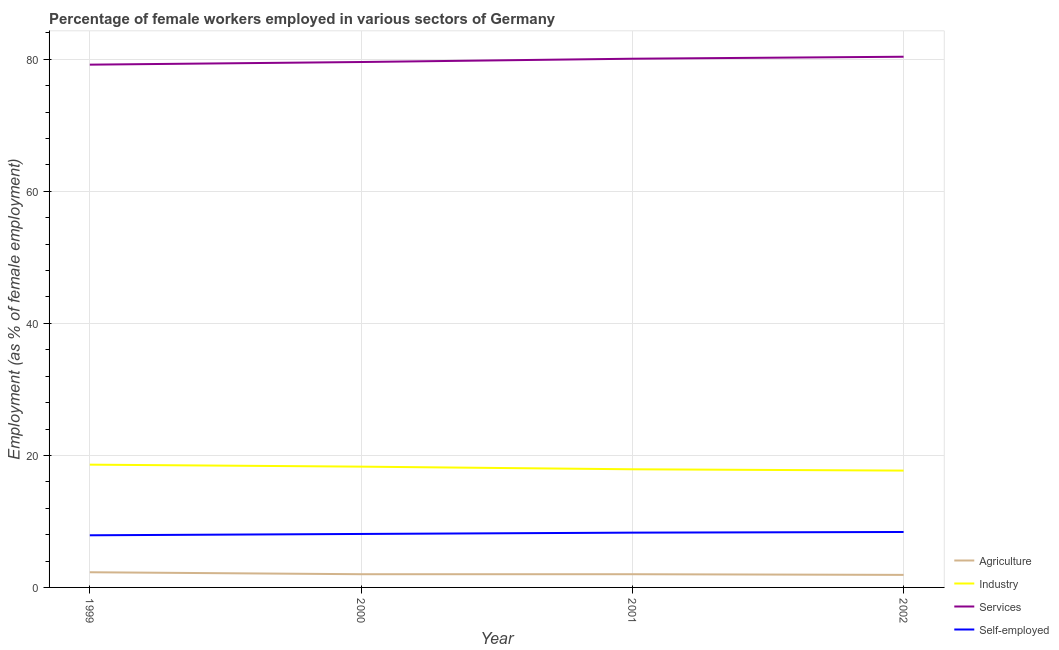How many different coloured lines are there?
Your answer should be very brief. 4. What is the percentage of female workers in industry in 2002?
Provide a short and direct response. 17.7. Across all years, what is the maximum percentage of self employed female workers?
Offer a very short reply. 8.4. Across all years, what is the minimum percentage of female workers in services?
Make the answer very short. 79.2. In which year was the percentage of self employed female workers minimum?
Give a very brief answer. 1999. What is the total percentage of self employed female workers in the graph?
Ensure brevity in your answer.  32.7. What is the difference between the percentage of self employed female workers in 2000 and that in 2002?
Your answer should be very brief. -0.3. What is the difference between the percentage of self employed female workers in 2002 and the percentage of female workers in services in 1999?
Give a very brief answer. -70.8. What is the average percentage of female workers in industry per year?
Keep it short and to the point. 18.12. In the year 2001, what is the difference between the percentage of self employed female workers and percentage of female workers in agriculture?
Offer a very short reply. 6.3. What is the ratio of the percentage of female workers in services in 2001 to that in 2002?
Keep it short and to the point. 1. What is the difference between the highest and the second highest percentage of female workers in services?
Your response must be concise. 0.3. What is the difference between the highest and the lowest percentage of female workers in agriculture?
Your answer should be compact. 0.4. In how many years, is the percentage of female workers in industry greater than the average percentage of female workers in industry taken over all years?
Give a very brief answer. 2. Does the percentage of female workers in agriculture monotonically increase over the years?
Offer a terse response. No. Is the percentage of female workers in agriculture strictly less than the percentage of female workers in services over the years?
Offer a very short reply. Yes. Are the values on the major ticks of Y-axis written in scientific E-notation?
Offer a terse response. No. Does the graph contain grids?
Ensure brevity in your answer.  Yes. How are the legend labels stacked?
Offer a terse response. Vertical. What is the title of the graph?
Give a very brief answer. Percentage of female workers employed in various sectors of Germany. Does "United Kingdom" appear as one of the legend labels in the graph?
Your response must be concise. No. What is the label or title of the Y-axis?
Ensure brevity in your answer.  Employment (as % of female employment). What is the Employment (as % of female employment) in Agriculture in 1999?
Provide a short and direct response. 2.3. What is the Employment (as % of female employment) of Industry in 1999?
Provide a short and direct response. 18.6. What is the Employment (as % of female employment) in Services in 1999?
Your answer should be compact. 79.2. What is the Employment (as % of female employment) of Self-employed in 1999?
Provide a short and direct response. 7.9. What is the Employment (as % of female employment) of Agriculture in 2000?
Keep it short and to the point. 2. What is the Employment (as % of female employment) of Industry in 2000?
Offer a terse response. 18.3. What is the Employment (as % of female employment) in Services in 2000?
Keep it short and to the point. 79.6. What is the Employment (as % of female employment) in Self-employed in 2000?
Make the answer very short. 8.1. What is the Employment (as % of female employment) of Agriculture in 2001?
Ensure brevity in your answer.  2. What is the Employment (as % of female employment) in Industry in 2001?
Provide a succinct answer. 17.9. What is the Employment (as % of female employment) in Services in 2001?
Make the answer very short. 80.1. What is the Employment (as % of female employment) in Self-employed in 2001?
Keep it short and to the point. 8.3. What is the Employment (as % of female employment) in Agriculture in 2002?
Offer a terse response. 1.9. What is the Employment (as % of female employment) of Industry in 2002?
Your response must be concise. 17.7. What is the Employment (as % of female employment) of Services in 2002?
Make the answer very short. 80.4. What is the Employment (as % of female employment) of Self-employed in 2002?
Provide a short and direct response. 8.4. Across all years, what is the maximum Employment (as % of female employment) in Agriculture?
Give a very brief answer. 2.3. Across all years, what is the maximum Employment (as % of female employment) in Industry?
Your answer should be compact. 18.6. Across all years, what is the maximum Employment (as % of female employment) in Services?
Give a very brief answer. 80.4. Across all years, what is the maximum Employment (as % of female employment) of Self-employed?
Provide a short and direct response. 8.4. Across all years, what is the minimum Employment (as % of female employment) in Agriculture?
Provide a succinct answer. 1.9. Across all years, what is the minimum Employment (as % of female employment) of Industry?
Offer a terse response. 17.7. Across all years, what is the minimum Employment (as % of female employment) of Services?
Make the answer very short. 79.2. Across all years, what is the minimum Employment (as % of female employment) of Self-employed?
Make the answer very short. 7.9. What is the total Employment (as % of female employment) in Agriculture in the graph?
Provide a short and direct response. 8.2. What is the total Employment (as % of female employment) in Industry in the graph?
Your answer should be compact. 72.5. What is the total Employment (as % of female employment) of Services in the graph?
Ensure brevity in your answer.  319.3. What is the total Employment (as % of female employment) of Self-employed in the graph?
Your answer should be very brief. 32.7. What is the difference between the Employment (as % of female employment) in Agriculture in 1999 and that in 2000?
Keep it short and to the point. 0.3. What is the difference between the Employment (as % of female employment) of Industry in 1999 and that in 2000?
Your answer should be compact. 0.3. What is the difference between the Employment (as % of female employment) of Self-employed in 1999 and that in 2000?
Make the answer very short. -0.2. What is the difference between the Employment (as % of female employment) of Agriculture in 1999 and that in 2001?
Your answer should be compact. 0.3. What is the difference between the Employment (as % of female employment) of Services in 1999 and that in 2001?
Offer a very short reply. -0.9. What is the difference between the Employment (as % of female employment) in Self-employed in 1999 and that in 2001?
Your answer should be very brief. -0.4. What is the difference between the Employment (as % of female employment) in Services in 1999 and that in 2002?
Provide a short and direct response. -1.2. What is the difference between the Employment (as % of female employment) in Self-employed in 1999 and that in 2002?
Your answer should be compact. -0.5. What is the difference between the Employment (as % of female employment) in Self-employed in 2000 and that in 2001?
Offer a terse response. -0.2. What is the difference between the Employment (as % of female employment) of Agriculture in 2000 and that in 2002?
Your response must be concise. 0.1. What is the difference between the Employment (as % of female employment) of Industry in 2000 and that in 2002?
Your answer should be very brief. 0.6. What is the difference between the Employment (as % of female employment) in Services in 2000 and that in 2002?
Your response must be concise. -0.8. What is the difference between the Employment (as % of female employment) of Agriculture in 2001 and that in 2002?
Your response must be concise. 0.1. What is the difference between the Employment (as % of female employment) of Agriculture in 1999 and the Employment (as % of female employment) of Services in 2000?
Your answer should be compact. -77.3. What is the difference between the Employment (as % of female employment) of Agriculture in 1999 and the Employment (as % of female employment) of Self-employed in 2000?
Ensure brevity in your answer.  -5.8. What is the difference between the Employment (as % of female employment) in Industry in 1999 and the Employment (as % of female employment) in Services in 2000?
Make the answer very short. -61. What is the difference between the Employment (as % of female employment) in Industry in 1999 and the Employment (as % of female employment) in Self-employed in 2000?
Ensure brevity in your answer.  10.5. What is the difference between the Employment (as % of female employment) of Services in 1999 and the Employment (as % of female employment) of Self-employed in 2000?
Your response must be concise. 71.1. What is the difference between the Employment (as % of female employment) in Agriculture in 1999 and the Employment (as % of female employment) in Industry in 2001?
Give a very brief answer. -15.6. What is the difference between the Employment (as % of female employment) of Agriculture in 1999 and the Employment (as % of female employment) of Services in 2001?
Your answer should be compact. -77.8. What is the difference between the Employment (as % of female employment) of Industry in 1999 and the Employment (as % of female employment) of Services in 2001?
Provide a short and direct response. -61.5. What is the difference between the Employment (as % of female employment) in Services in 1999 and the Employment (as % of female employment) in Self-employed in 2001?
Your answer should be compact. 70.9. What is the difference between the Employment (as % of female employment) in Agriculture in 1999 and the Employment (as % of female employment) in Industry in 2002?
Provide a succinct answer. -15.4. What is the difference between the Employment (as % of female employment) of Agriculture in 1999 and the Employment (as % of female employment) of Services in 2002?
Your answer should be very brief. -78.1. What is the difference between the Employment (as % of female employment) in Industry in 1999 and the Employment (as % of female employment) in Services in 2002?
Give a very brief answer. -61.8. What is the difference between the Employment (as % of female employment) of Services in 1999 and the Employment (as % of female employment) of Self-employed in 2002?
Your response must be concise. 70.8. What is the difference between the Employment (as % of female employment) of Agriculture in 2000 and the Employment (as % of female employment) of Industry in 2001?
Your answer should be compact. -15.9. What is the difference between the Employment (as % of female employment) in Agriculture in 2000 and the Employment (as % of female employment) in Services in 2001?
Give a very brief answer. -78.1. What is the difference between the Employment (as % of female employment) in Industry in 2000 and the Employment (as % of female employment) in Services in 2001?
Keep it short and to the point. -61.8. What is the difference between the Employment (as % of female employment) in Industry in 2000 and the Employment (as % of female employment) in Self-employed in 2001?
Your response must be concise. 10. What is the difference between the Employment (as % of female employment) in Services in 2000 and the Employment (as % of female employment) in Self-employed in 2001?
Offer a very short reply. 71.3. What is the difference between the Employment (as % of female employment) in Agriculture in 2000 and the Employment (as % of female employment) in Industry in 2002?
Give a very brief answer. -15.7. What is the difference between the Employment (as % of female employment) in Agriculture in 2000 and the Employment (as % of female employment) in Services in 2002?
Your answer should be compact. -78.4. What is the difference between the Employment (as % of female employment) of Industry in 2000 and the Employment (as % of female employment) of Services in 2002?
Ensure brevity in your answer.  -62.1. What is the difference between the Employment (as % of female employment) in Industry in 2000 and the Employment (as % of female employment) in Self-employed in 2002?
Make the answer very short. 9.9. What is the difference between the Employment (as % of female employment) of Services in 2000 and the Employment (as % of female employment) of Self-employed in 2002?
Your response must be concise. 71.2. What is the difference between the Employment (as % of female employment) in Agriculture in 2001 and the Employment (as % of female employment) in Industry in 2002?
Keep it short and to the point. -15.7. What is the difference between the Employment (as % of female employment) in Agriculture in 2001 and the Employment (as % of female employment) in Services in 2002?
Give a very brief answer. -78.4. What is the difference between the Employment (as % of female employment) of Agriculture in 2001 and the Employment (as % of female employment) of Self-employed in 2002?
Provide a succinct answer. -6.4. What is the difference between the Employment (as % of female employment) in Industry in 2001 and the Employment (as % of female employment) in Services in 2002?
Give a very brief answer. -62.5. What is the difference between the Employment (as % of female employment) of Industry in 2001 and the Employment (as % of female employment) of Self-employed in 2002?
Give a very brief answer. 9.5. What is the difference between the Employment (as % of female employment) of Services in 2001 and the Employment (as % of female employment) of Self-employed in 2002?
Offer a terse response. 71.7. What is the average Employment (as % of female employment) of Agriculture per year?
Give a very brief answer. 2.05. What is the average Employment (as % of female employment) in Industry per year?
Provide a succinct answer. 18.12. What is the average Employment (as % of female employment) in Services per year?
Provide a succinct answer. 79.83. What is the average Employment (as % of female employment) of Self-employed per year?
Keep it short and to the point. 8.18. In the year 1999, what is the difference between the Employment (as % of female employment) of Agriculture and Employment (as % of female employment) of Industry?
Provide a succinct answer. -16.3. In the year 1999, what is the difference between the Employment (as % of female employment) of Agriculture and Employment (as % of female employment) of Services?
Provide a short and direct response. -76.9. In the year 1999, what is the difference between the Employment (as % of female employment) in Industry and Employment (as % of female employment) in Services?
Provide a succinct answer. -60.6. In the year 1999, what is the difference between the Employment (as % of female employment) of Industry and Employment (as % of female employment) of Self-employed?
Give a very brief answer. 10.7. In the year 1999, what is the difference between the Employment (as % of female employment) in Services and Employment (as % of female employment) in Self-employed?
Make the answer very short. 71.3. In the year 2000, what is the difference between the Employment (as % of female employment) of Agriculture and Employment (as % of female employment) of Industry?
Keep it short and to the point. -16.3. In the year 2000, what is the difference between the Employment (as % of female employment) in Agriculture and Employment (as % of female employment) in Services?
Provide a short and direct response. -77.6. In the year 2000, what is the difference between the Employment (as % of female employment) of Industry and Employment (as % of female employment) of Services?
Make the answer very short. -61.3. In the year 2000, what is the difference between the Employment (as % of female employment) in Services and Employment (as % of female employment) in Self-employed?
Keep it short and to the point. 71.5. In the year 2001, what is the difference between the Employment (as % of female employment) of Agriculture and Employment (as % of female employment) of Industry?
Provide a succinct answer. -15.9. In the year 2001, what is the difference between the Employment (as % of female employment) of Agriculture and Employment (as % of female employment) of Services?
Offer a very short reply. -78.1. In the year 2001, what is the difference between the Employment (as % of female employment) of Agriculture and Employment (as % of female employment) of Self-employed?
Your response must be concise. -6.3. In the year 2001, what is the difference between the Employment (as % of female employment) in Industry and Employment (as % of female employment) in Services?
Make the answer very short. -62.2. In the year 2001, what is the difference between the Employment (as % of female employment) of Industry and Employment (as % of female employment) of Self-employed?
Offer a very short reply. 9.6. In the year 2001, what is the difference between the Employment (as % of female employment) of Services and Employment (as % of female employment) of Self-employed?
Provide a short and direct response. 71.8. In the year 2002, what is the difference between the Employment (as % of female employment) of Agriculture and Employment (as % of female employment) of Industry?
Keep it short and to the point. -15.8. In the year 2002, what is the difference between the Employment (as % of female employment) of Agriculture and Employment (as % of female employment) of Services?
Your answer should be compact. -78.5. In the year 2002, what is the difference between the Employment (as % of female employment) in Industry and Employment (as % of female employment) in Services?
Your answer should be compact. -62.7. What is the ratio of the Employment (as % of female employment) in Agriculture in 1999 to that in 2000?
Keep it short and to the point. 1.15. What is the ratio of the Employment (as % of female employment) in Industry in 1999 to that in 2000?
Keep it short and to the point. 1.02. What is the ratio of the Employment (as % of female employment) in Services in 1999 to that in 2000?
Keep it short and to the point. 0.99. What is the ratio of the Employment (as % of female employment) in Self-employed in 1999 to that in 2000?
Your answer should be very brief. 0.98. What is the ratio of the Employment (as % of female employment) of Agriculture in 1999 to that in 2001?
Give a very brief answer. 1.15. What is the ratio of the Employment (as % of female employment) of Industry in 1999 to that in 2001?
Provide a succinct answer. 1.04. What is the ratio of the Employment (as % of female employment) in Services in 1999 to that in 2001?
Provide a short and direct response. 0.99. What is the ratio of the Employment (as % of female employment) of Self-employed in 1999 to that in 2001?
Keep it short and to the point. 0.95. What is the ratio of the Employment (as % of female employment) in Agriculture in 1999 to that in 2002?
Your answer should be very brief. 1.21. What is the ratio of the Employment (as % of female employment) of Industry in 1999 to that in 2002?
Offer a very short reply. 1.05. What is the ratio of the Employment (as % of female employment) in Services in 1999 to that in 2002?
Provide a succinct answer. 0.99. What is the ratio of the Employment (as % of female employment) in Self-employed in 1999 to that in 2002?
Ensure brevity in your answer.  0.94. What is the ratio of the Employment (as % of female employment) in Agriculture in 2000 to that in 2001?
Offer a terse response. 1. What is the ratio of the Employment (as % of female employment) of Industry in 2000 to that in 2001?
Keep it short and to the point. 1.02. What is the ratio of the Employment (as % of female employment) in Services in 2000 to that in 2001?
Your answer should be very brief. 0.99. What is the ratio of the Employment (as % of female employment) of Self-employed in 2000 to that in 2001?
Your response must be concise. 0.98. What is the ratio of the Employment (as % of female employment) in Agriculture in 2000 to that in 2002?
Your answer should be very brief. 1.05. What is the ratio of the Employment (as % of female employment) of Industry in 2000 to that in 2002?
Your response must be concise. 1.03. What is the ratio of the Employment (as % of female employment) in Services in 2000 to that in 2002?
Make the answer very short. 0.99. What is the ratio of the Employment (as % of female employment) in Self-employed in 2000 to that in 2002?
Your answer should be compact. 0.96. What is the ratio of the Employment (as % of female employment) in Agriculture in 2001 to that in 2002?
Your answer should be very brief. 1.05. What is the ratio of the Employment (as % of female employment) in Industry in 2001 to that in 2002?
Your answer should be compact. 1.01. What is the ratio of the Employment (as % of female employment) in Services in 2001 to that in 2002?
Provide a short and direct response. 1. What is the difference between the highest and the second highest Employment (as % of female employment) of Agriculture?
Provide a short and direct response. 0.3. What is the difference between the highest and the second highest Employment (as % of female employment) in Industry?
Your answer should be very brief. 0.3. What is the difference between the highest and the second highest Employment (as % of female employment) in Services?
Your response must be concise. 0.3. 